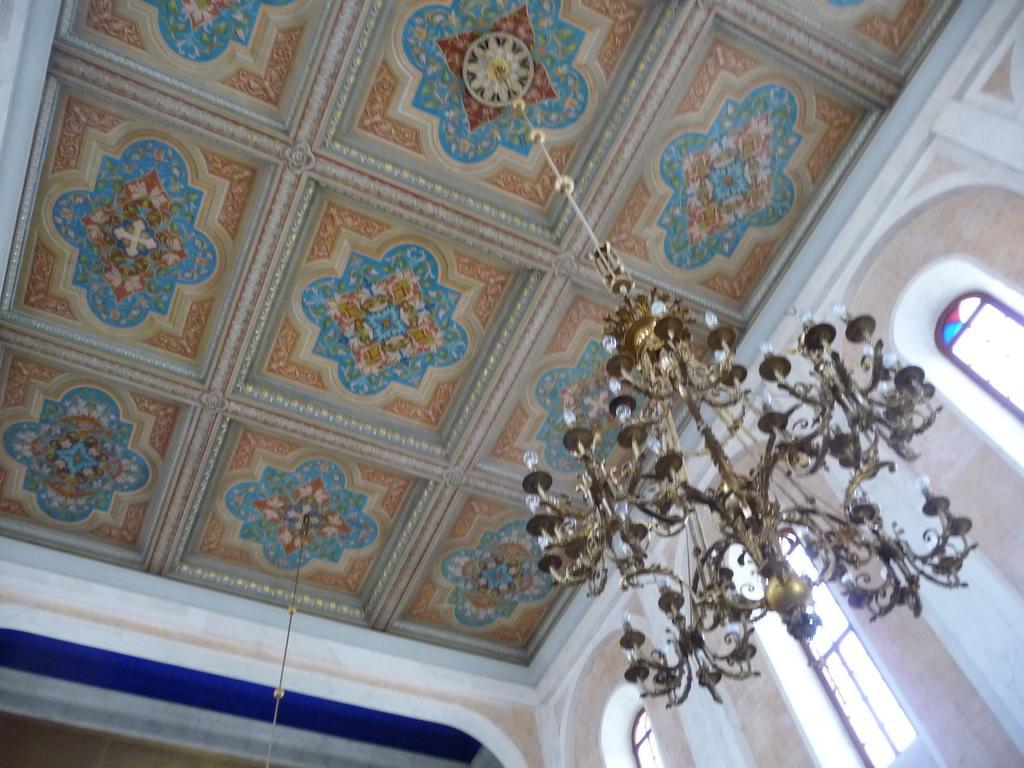Please provide a concise description of this image. This is an inside view of a room. On the right side, I can see the wall along with the windows. Here I can see a chandelier which is hanging to the top. 